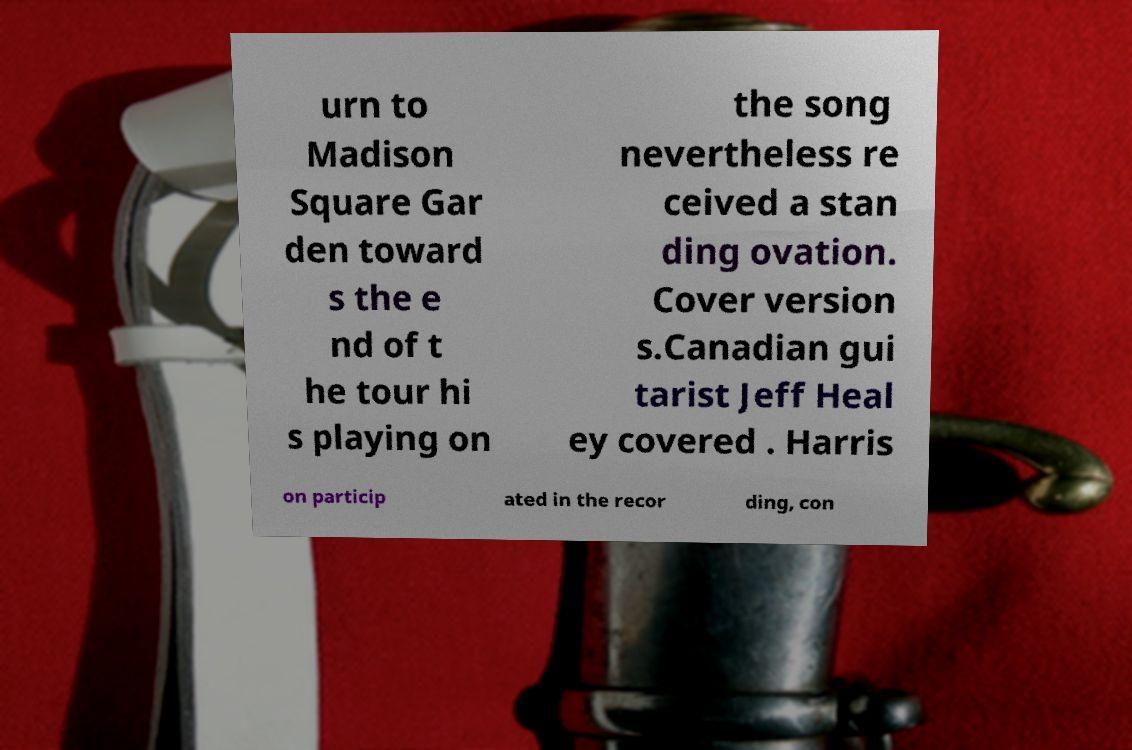Please identify and transcribe the text found in this image. urn to Madison Square Gar den toward s the e nd of t he tour hi s playing on the song nevertheless re ceived a stan ding ovation. Cover version s.Canadian gui tarist Jeff Heal ey covered . Harris on particip ated in the recor ding, con 